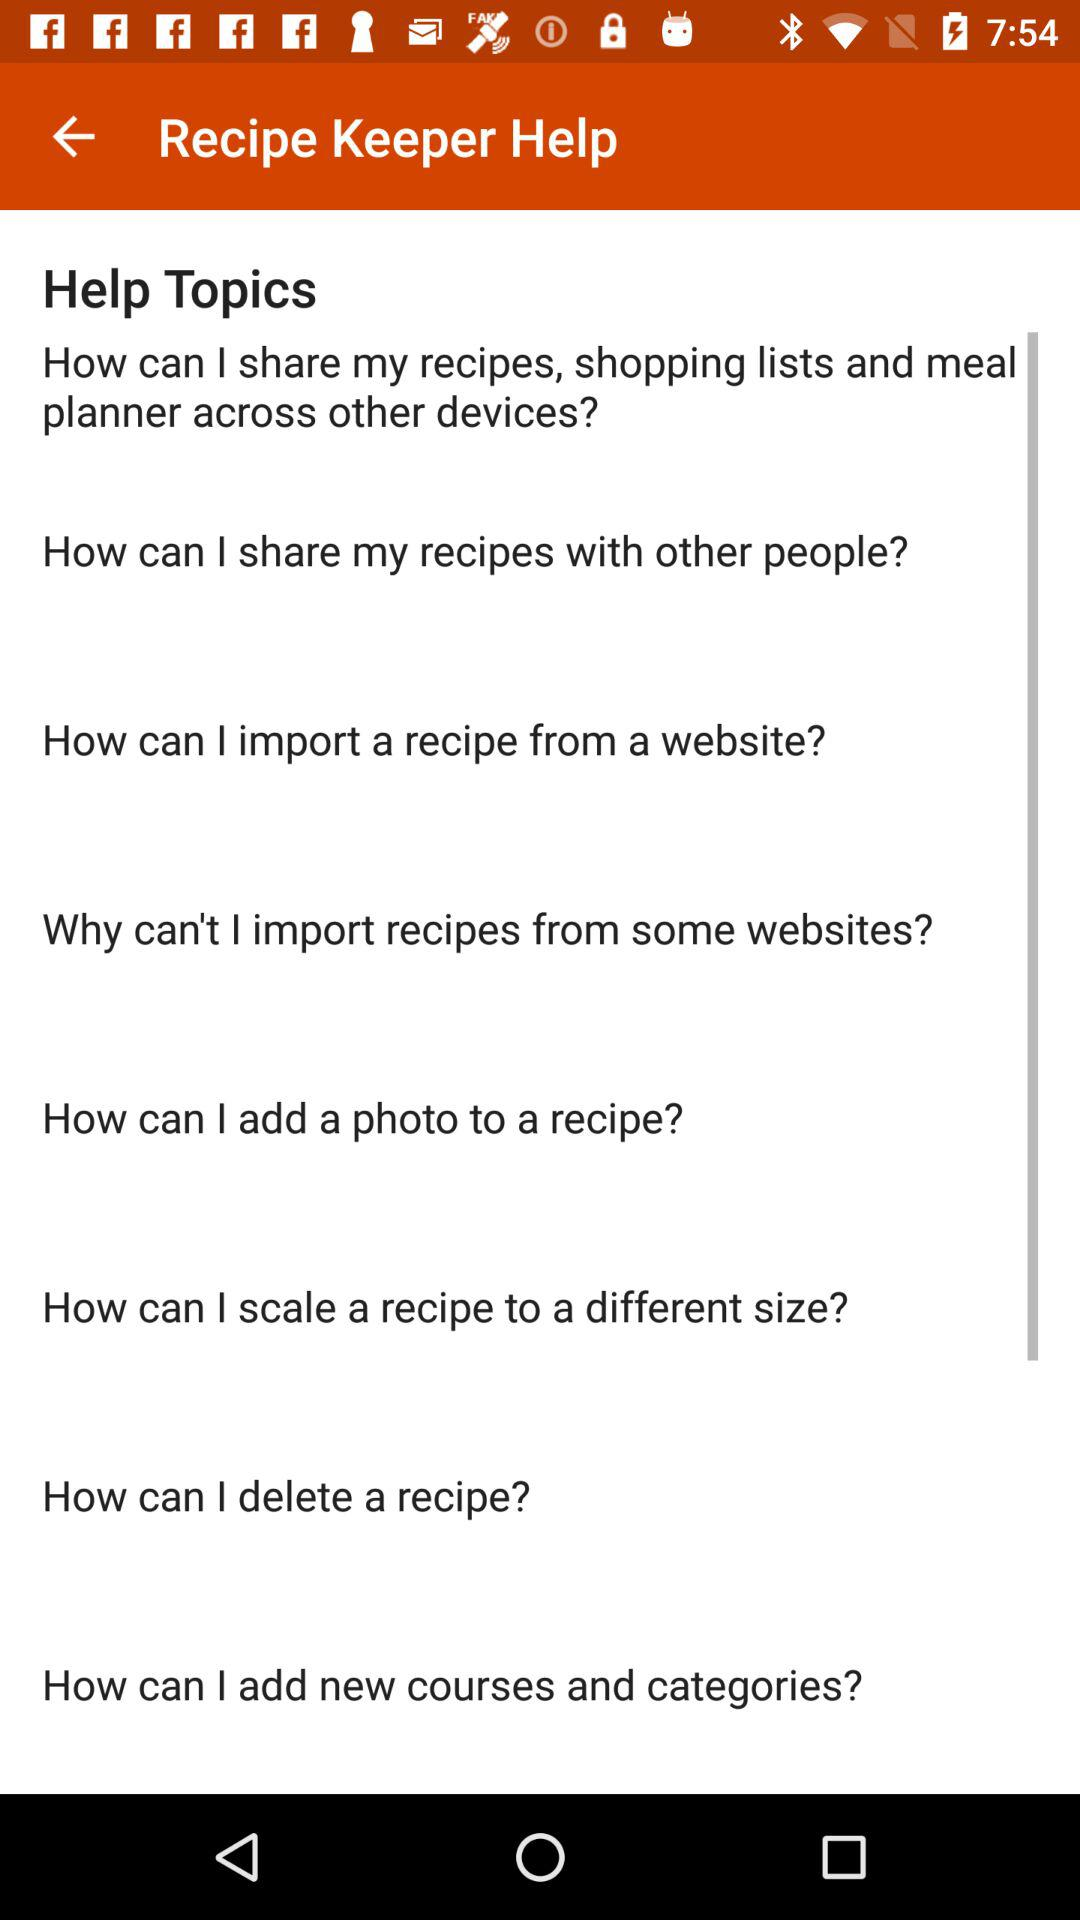How can a recipe be deleted?
When the provided information is insufficient, respond with <no answer>. <no answer> 